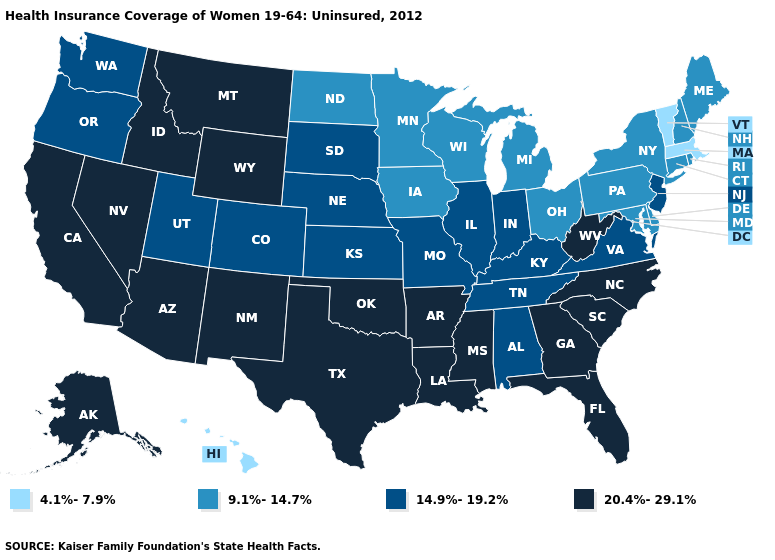What is the value of Oregon?
Keep it brief. 14.9%-19.2%. What is the highest value in the West ?
Keep it brief. 20.4%-29.1%. Name the states that have a value in the range 14.9%-19.2%?
Give a very brief answer. Alabama, Colorado, Illinois, Indiana, Kansas, Kentucky, Missouri, Nebraska, New Jersey, Oregon, South Dakota, Tennessee, Utah, Virginia, Washington. Name the states that have a value in the range 4.1%-7.9%?
Answer briefly. Hawaii, Massachusetts, Vermont. Does Michigan have the highest value in the MidWest?
Be succinct. No. Does New Jersey have a higher value than Minnesota?
Concise answer only. Yes. How many symbols are there in the legend?
Give a very brief answer. 4. Among the states that border Arkansas , which have the lowest value?
Short answer required. Missouri, Tennessee. What is the value of Florida?
Answer briefly. 20.4%-29.1%. Which states have the lowest value in the USA?
Write a very short answer. Hawaii, Massachusetts, Vermont. What is the value of Maine?
Write a very short answer. 9.1%-14.7%. Name the states that have a value in the range 4.1%-7.9%?
Short answer required. Hawaii, Massachusetts, Vermont. What is the value of Missouri?
Give a very brief answer. 14.9%-19.2%. Is the legend a continuous bar?
Be succinct. No. Does Georgia have a higher value than Indiana?
Answer briefly. Yes. 